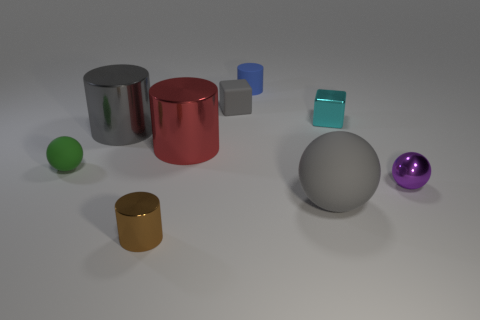Add 1 small metal things. How many objects exist? 10 Subtract all balls. How many objects are left? 6 Add 9 cyan things. How many cyan things are left? 10 Add 5 tiny cyan blocks. How many tiny cyan blocks exist? 6 Subtract 1 red cylinders. How many objects are left? 8 Subtract all tiny blue rubber cylinders. Subtract all brown shiny objects. How many objects are left? 7 